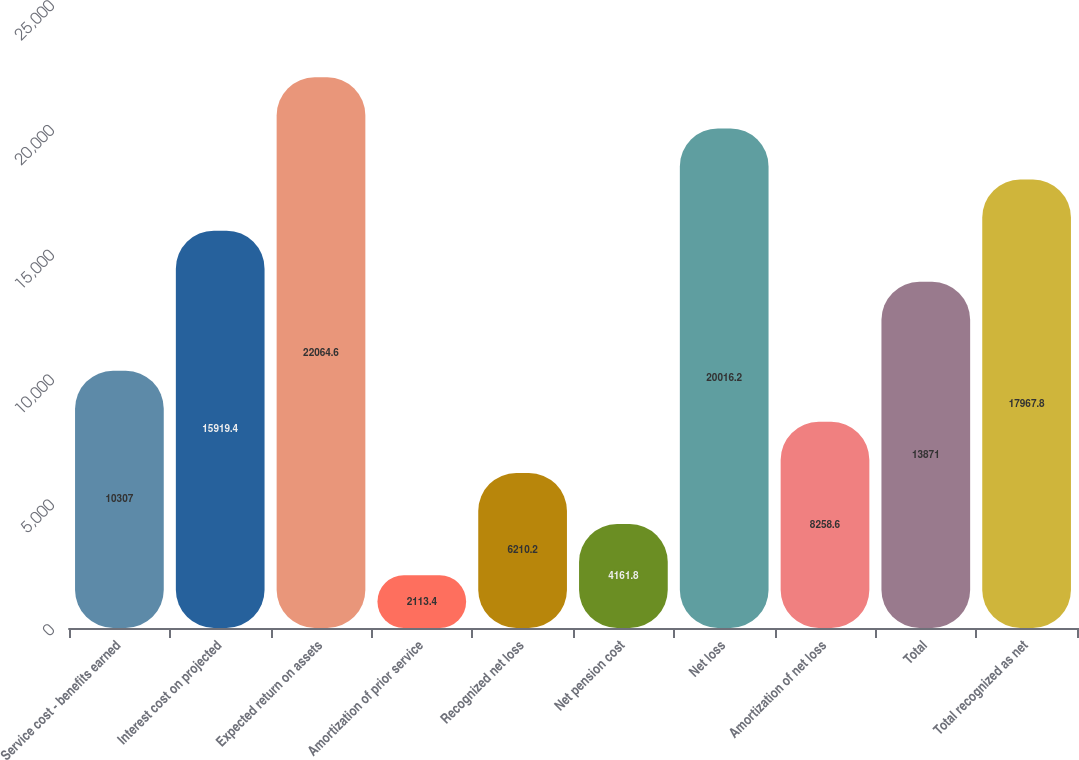Convert chart. <chart><loc_0><loc_0><loc_500><loc_500><bar_chart><fcel>Service cost - benefits earned<fcel>Interest cost on projected<fcel>Expected return on assets<fcel>Amortization of prior service<fcel>Recognized net loss<fcel>Net pension cost<fcel>Net loss<fcel>Amortization of net loss<fcel>Total<fcel>Total recognized as net<nl><fcel>10307<fcel>15919.4<fcel>22064.6<fcel>2113.4<fcel>6210.2<fcel>4161.8<fcel>20016.2<fcel>8258.6<fcel>13871<fcel>17967.8<nl></chart> 